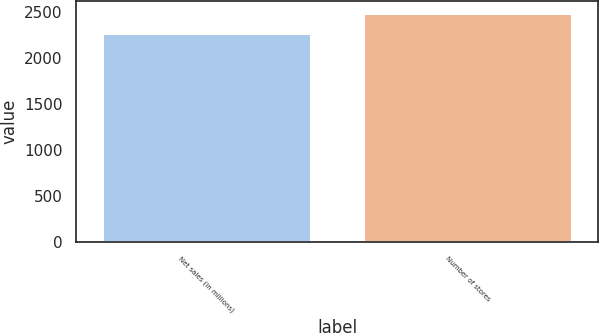<chart> <loc_0><loc_0><loc_500><loc_500><bar_chart><fcel>Net sales (in millions)<fcel>Number of stores<nl><fcel>2269.5<fcel>2490<nl></chart> 